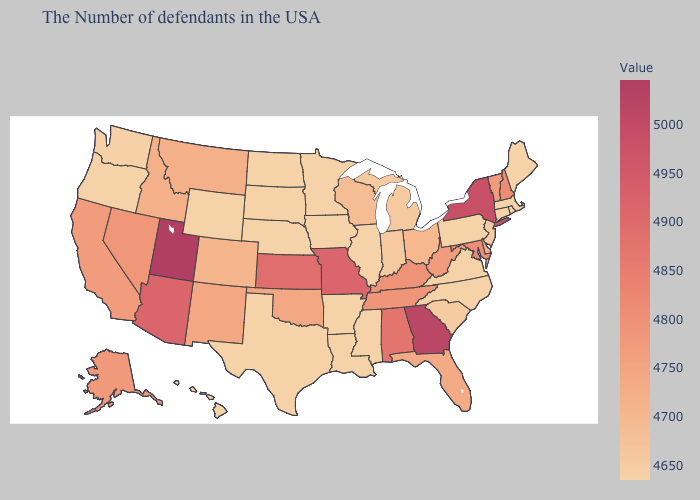Does Utah have the lowest value in the West?
Keep it brief. No. Among the states that border Pennsylvania , does New York have the highest value?
Quick response, please. Yes. Does Arizona have a higher value than Maryland?
Give a very brief answer. Yes. Does Oregon have a higher value than New Hampshire?
Answer briefly. No. Which states have the lowest value in the West?
Quick response, please. Wyoming, Oregon, Hawaii. Does South Dakota have the lowest value in the USA?
Answer briefly. Yes. Which states have the lowest value in the USA?
Give a very brief answer. Maine, Massachusetts, Rhode Island, Connecticut, Pennsylvania, Virginia, North Carolina, Illinois, Mississippi, Louisiana, Arkansas, Minnesota, Iowa, Nebraska, Texas, South Dakota, North Dakota, Wyoming, Oregon, Hawaii. 